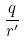<formula> <loc_0><loc_0><loc_500><loc_500>\frac { q } { r ^ { \prime } }</formula> 